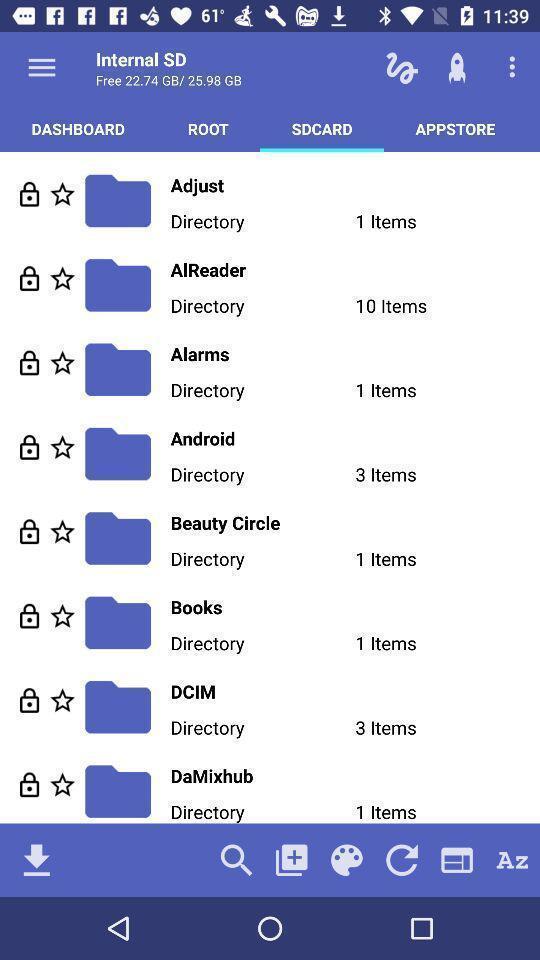What can you discern from this picture? Page displaying multiple options. 